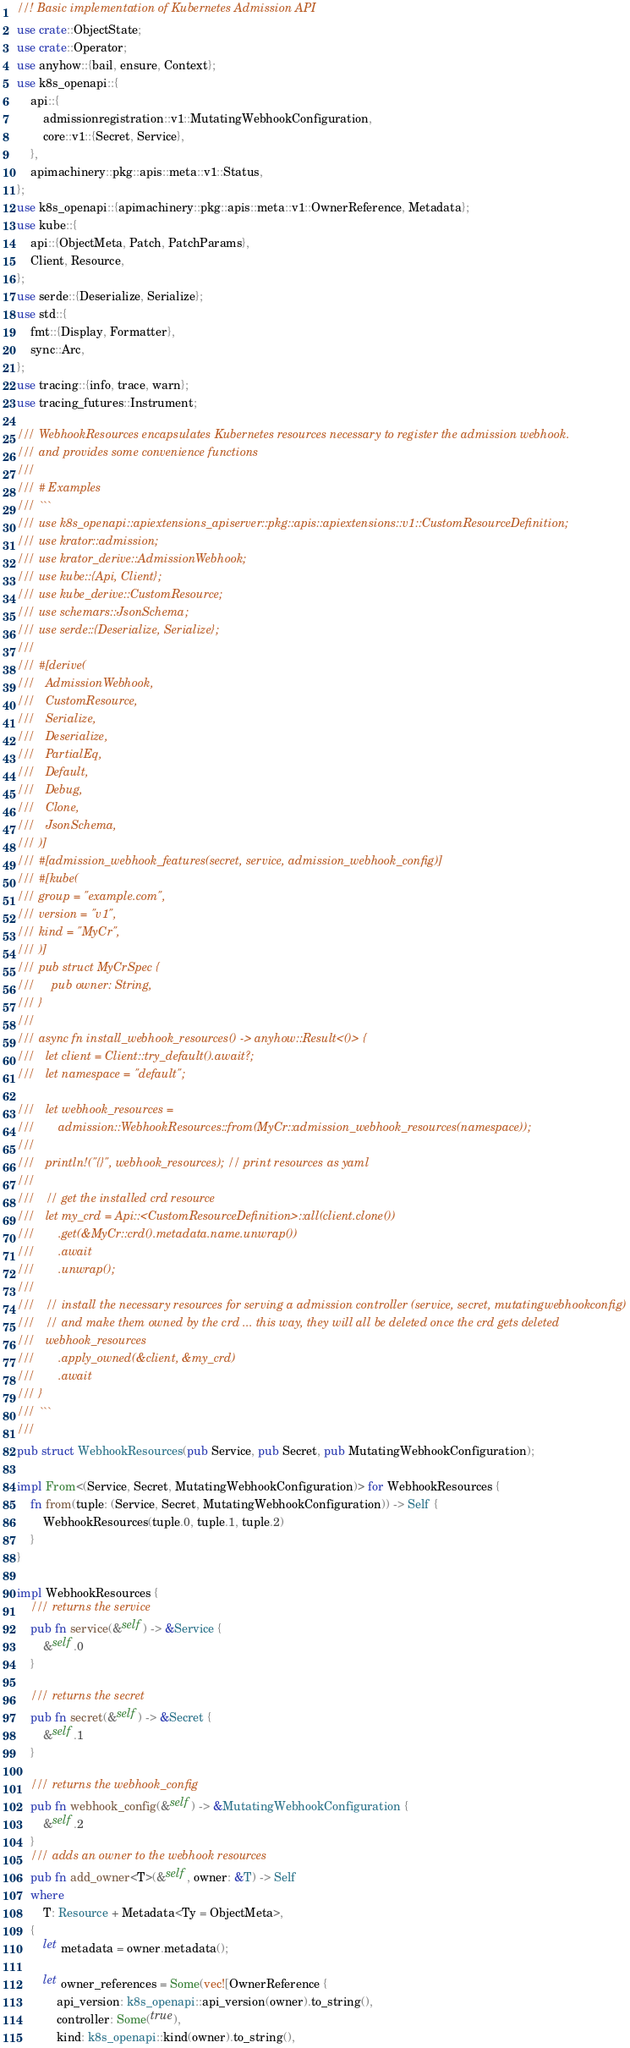Convert code to text. <code><loc_0><loc_0><loc_500><loc_500><_Rust_>//! Basic implementation of Kubernetes Admission API
use crate::ObjectState;
use crate::Operator;
use anyhow::{bail, ensure, Context};
use k8s_openapi::{
    api::{
        admissionregistration::v1::MutatingWebhookConfiguration,
        core::v1::{Secret, Service},
    },
    apimachinery::pkg::apis::meta::v1::Status,
};
use k8s_openapi::{apimachinery::pkg::apis::meta::v1::OwnerReference, Metadata};
use kube::{
    api::{ObjectMeta, Patch, PatchParams},
    Client, Resource,
};
use serde::{Deserialize, Serialize};
use std::{
    fmt::{Display, Formatter},
    sync::Arc,
};
use tracing::{info, trace, warn};
use tracing_futures::Instrument;

/// WebhookResources encapsulates Kubernetes resources necessary to register the admission webhook.
/// and provides some convenience functions
///
/// # Examples
/// ```
/// use k8s_openapi::apiextensions_apiserver::pkg::apis::apiextensions::v1::CustomResourceDefinition;
/// use krator::admission;
/// use krator_derive::AdmissionWebhook;
/// use kube::{Api, Client};
/// use kube_derive::CustomResource;
/// use schemars::JsonSchema;
/// use serde::{Deserialize, Serialize};
///
/// #[derive(
///   AdmissionWebhook,
///   CustomResource,
///   Serialize,
///   Deserialize,
///   PartialEq,
///   Default,
///   Debug,
///   Clone,
///   JsonSchema,
/// )]
/// #[admission_webhook_features(secret, service, admission_webhook_config)]
/// #[kube(
/// group = "example.com",
/// version = "v1",
/// kind = "MyCr",
/// )]
/// pub struct MyCrSpec {
///     pub owner: String,
/// }
///
/// async fn install_webhook_resources() -> anyhow::Result<()> {
///   let client = Client::try_default().await?;
///   let namespace = "default";

///   let webhook_resources =
///       admission::WebhookResources::from(MyCr::admission_webhook_resources(namespace));
///
///   println!("{}", webhook_resources); // print resources as yaml
///
///   // get the installed crd resource
///   let my_crd = Api::<CustomResourceDefinition>::all(client.clone())
///       .get(&MyCr::crd().metadata.name.unwrap())
///       .await
///       .unwrap();
///
///   // install the necessary resources for serving a admission controller (service, secret, mutatingwebhookconfig)
///   // and make them owned by the crd ... this way, they will all be deleted once the crd gets deleted
///   webhook_resources
///       .apply_owned(&client, &my_crd)
///       .await
/// }
/// ```
///
pub struct WebhookResources(pub Service, pub Secret, pub MutatingWebhookConfiguration);

impl From<(Service, Secret, MutatingWebhookConfiguration)> for WebhookResources {
    fn from(tuple: (Service, Secret, MutatingWebhookConfiguration)) -> Self {
        WebhookResources(tuple.0, tuple.1, tuple.2)
    }
}

impl WebhookResources {
    /// returns the service
    pub fn service(&self) -> &Service {
        &self.0
    }

    /// returns the secret
    pub fn secret(&self) -> &Secret {
        &self.1
    }

    /// returns the webhook_config
    pub fn webhook_config(&self) -> &MutatingWebhookConfiguration {
        &self.2
    }
    /// adds an owner to the webhook resources
    pub fn add_owner<T>(&self, owner: &T) -> Self
    where
        T: Resource + Metadata<Ty = ObjectMeta>,
    {
        let metadata = owner.metadata();

        let owner_references = Some(vec![OwnerReference {
            api_version: k8s_openapi::api_version(owner).to_string(),
            controller: Some(true),
            kind: k8s_openapi::kind(owner).to_string(),</code> 